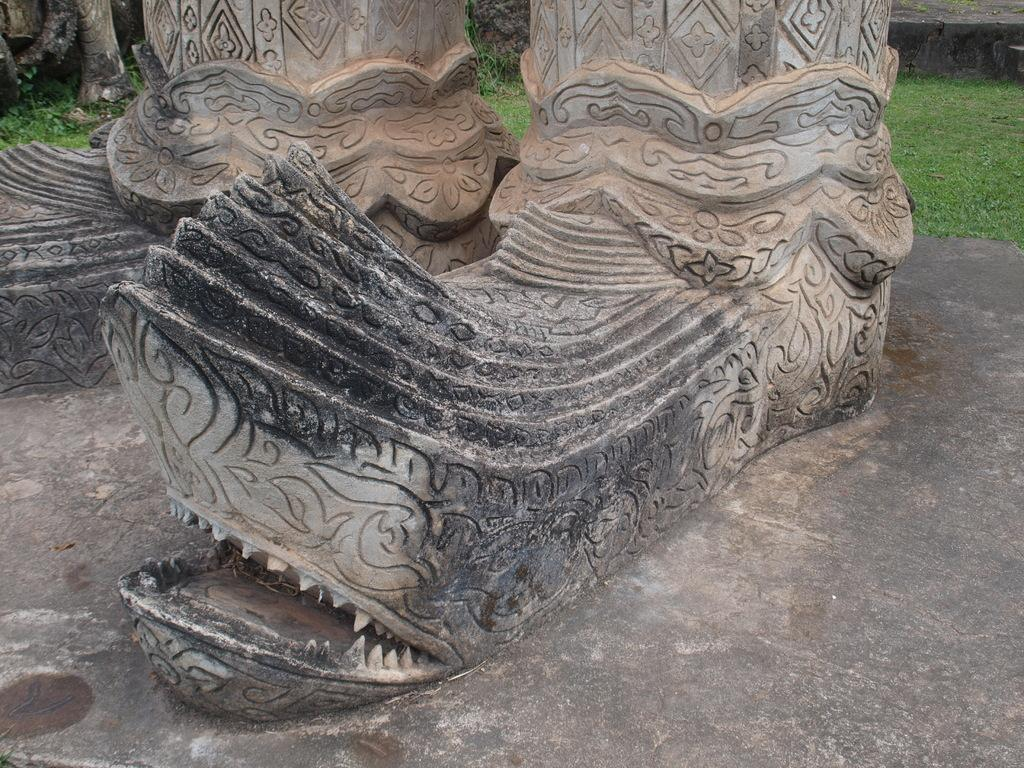What is the main subject in the image? There is a sculpture in the image. What type of vegetation is on the right side of the image? There is grass on the right side of the image. What can be seen in the background of the image? There are constructions visible in the background of the image. What type of linen is used to cover the sculpture in the image? There is no linen present in the image, and the sculpture is not covered. What is the taste of the sculpture in the image? Sculptures are not edible and therefore have no taste. 